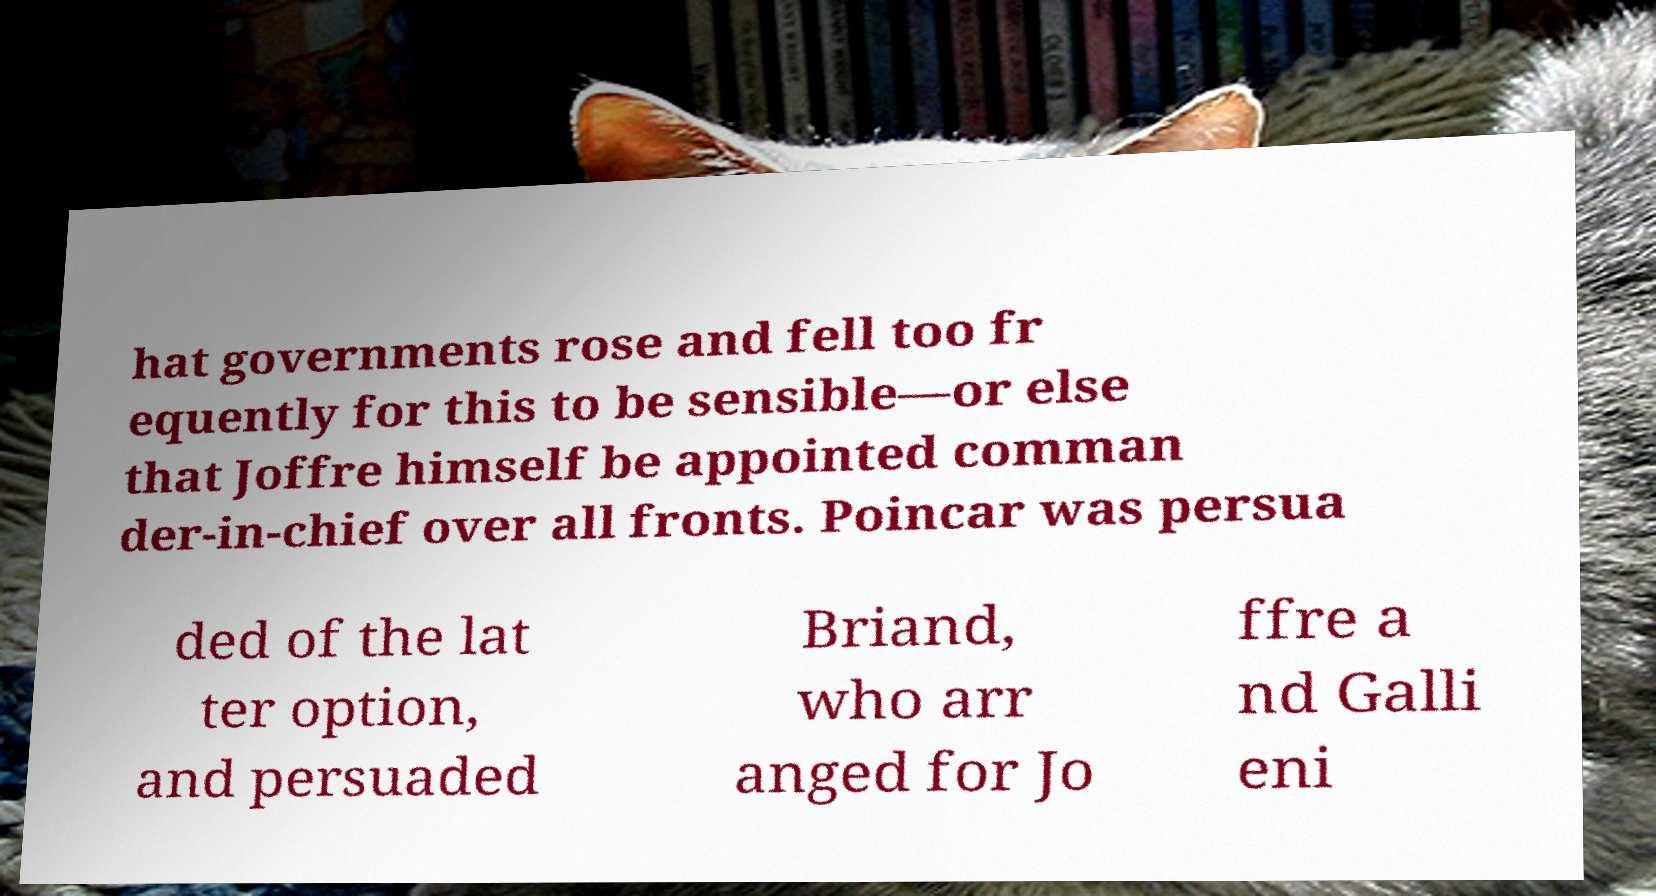Can you accurately transcribe the text from the provided image for me? hat governments rose and fell too fr equently for this to be sensible—or else that Joffre himself be appointed comman der-in-chief over all fronts. Poincar was persua ded of the lat ter option, and persuaded Briand, who arr anged for Jo ffre a nd Galli eni 